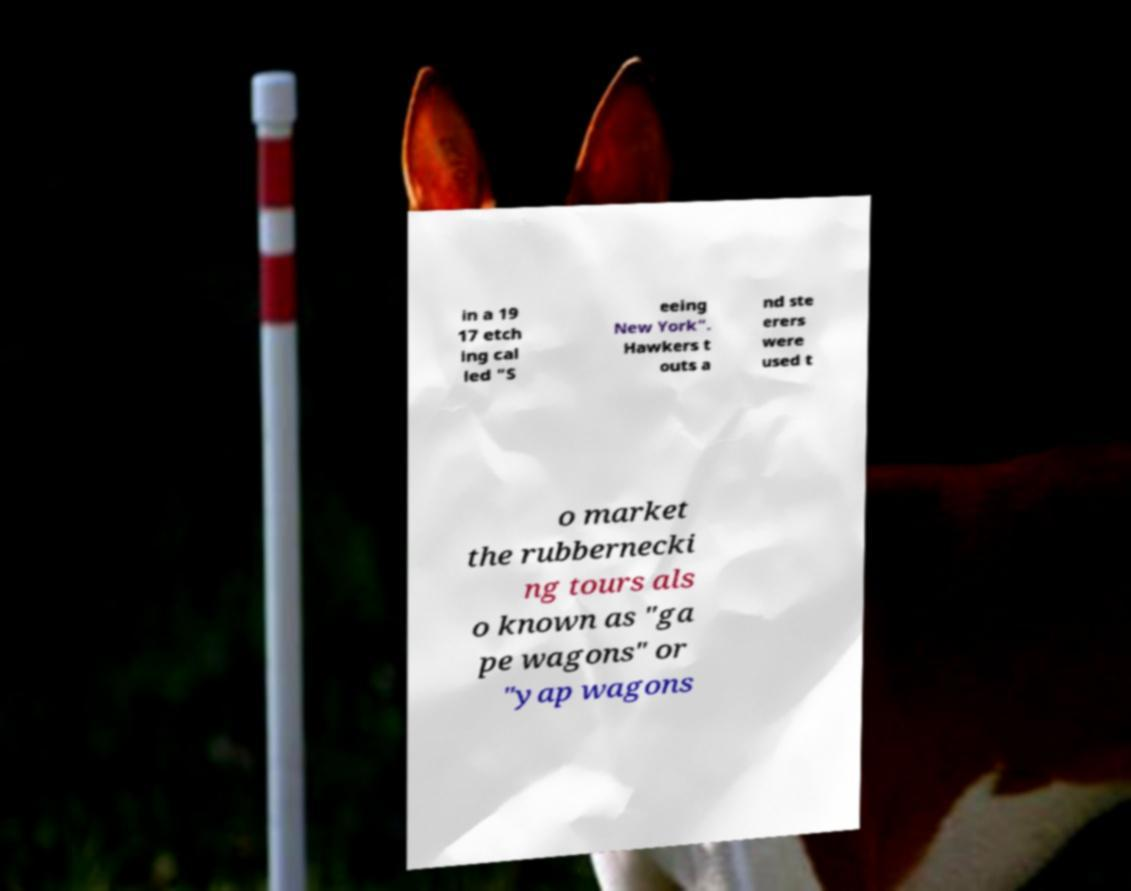Could you extract and type out the text from this image? in a 19 17 etch ing cal led "S eeing New York". Hawkers t outs a nd ste erers were used t o market the rubbernecki ng tours als o known as "ga pe wagons" or "yap wagons 